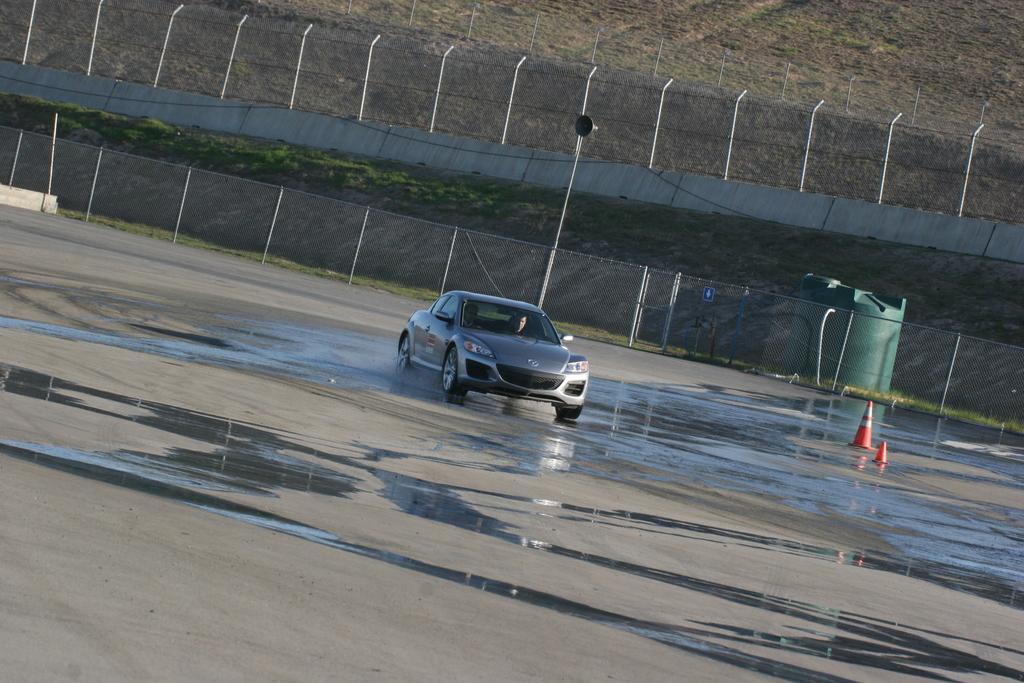Please provide a concise description of this image. In this image, in the middle, we can see a car moving the road. In the background, we can see net fence, metal poles and a grass. 